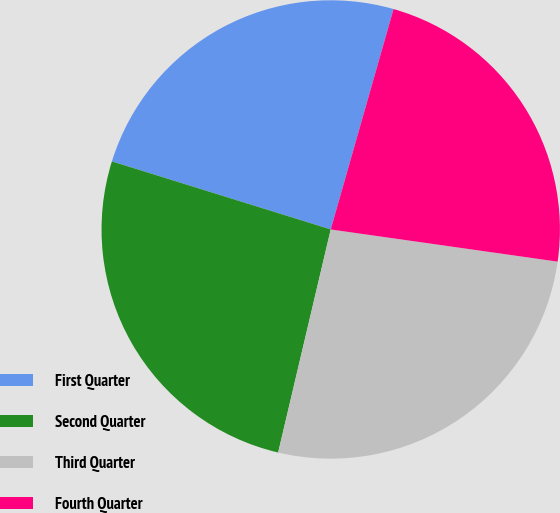<chart> <loc_0><loc_0><loc_500><loc_500><pie_chart><fcel>First Quarter<fcel>Second Quarter<fcel>Third Quarter<fcel>Fourth Quarter<nl><fcel>24.62%<fcel>26.11%<fcel>26.44%<fcel>22.82%<nl></chart> 